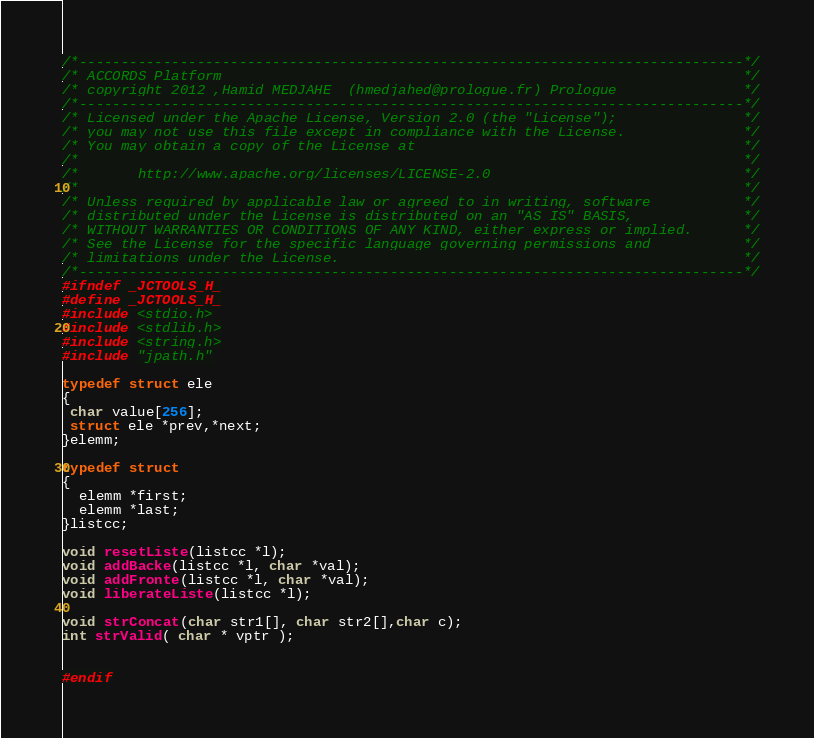<code> <loc_0><loc_0><loc_500><loc_500><_C_>/*-------------------------------------------------------------------------------*/
/* ACCORDS Platform                                                              */
/* copyright 2012 ,Hamid MEDJAHE  (hmedjahed@prologue.fr) Prologue               */
/*-------------------------------------------------------------------------------*/
/* Licensed under the Apache License, Version 2.0 (the "License");               */
/* you may not use this file except in compliance with the License.              */
/* You may obtain a copy of the License at                                       */
/*                                                                               */
/*       http://www.apache.org/licenses/LICENSE-2.0                              */
/*                                                                               */
/* Unless required by applicable law or agreed to in writing, software           */
/* distributed under the License is distributed on an "AS IS" BASIS,             */
/* WITHOUT WARRANTIES OR CONDITIONS OF ANY KIND, either express or implied.      */
/* See the License for the specific language governing permissions and           */
/* limitations under the License.                                                */
/*-------------------------------------------------------------------------------*/
#ifndef _JCTOOLS_H_
#define _JCTOOLS_H_
#include <stdio.h>
#include <stdlib.h>
#include <string.h>
#include "jpath.h"

typedef struct ele
{
 char value[256];
 struct ele *prev,*next;
}elemm;

typedef struct
{
  elemm *first;
  elemm *last;
}listcc;

void resetListe(listcc *l);
void addBacke(listcc *l, char *val);
void addFronte(listcc *l, char *val);
void liberateListe(listcc *l);

void strConcat(char str1[], char str2[],char c);
int strValid( char * vptr );


#endif

</code> 